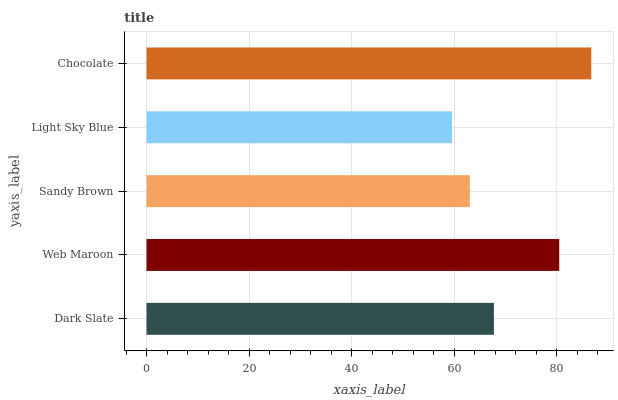Is Light Sky Blue the minimum?
Answer yes or no. Yes. Is Chocolate the maximum?
Answer yes or no. Yes. Is Web Maroon the minimum?
Answer yes or no. No. Is Web Maroon the maximum?
Answer yes or no. No. Is Web Maroon greater than Dark Slate?
Answer yes or no. Yes. Is Dark Slate less than Web Maroon?
Answer yes or no. Yes. Is Dark Slate greater than Web Maroon?
Answer yes or no. No. Is Web Maroon less than Dark Slate?
Answer yes or no. No. Is Dark Slate the high median?
Answer yes or no. Yes. Is Dark Slate the low median?
Answer yes or no. Yes. Is Chocolate the high median?
Answer yes or no. No. Is Light Sky Blue the low median?
Answer yes or no. No. 